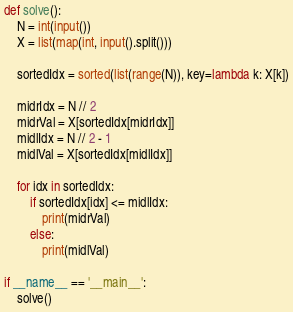<code> <loc_0><loc_0><loc_500><loc_500><_Python_>def solve():
    N = int(input())
    X = list(map(int, input().split()))

    sortedIdx = sorted(list(range(N)), key=lambda k: X[k])

    midrIdx = N // 2
    midrVal = X[sortedIdx[midrIdx]]
    midlIdx = N // 2 - 1
    midlVal = X[sortedIdx[midlIdx]]

    for idx in sortedIdx:
        if sortedIdx[idx] <= midlIdx:
            print(midrVal)
        else:
            print(midlVal)
    
if __name__ == '__main__':
    solve()</code> 